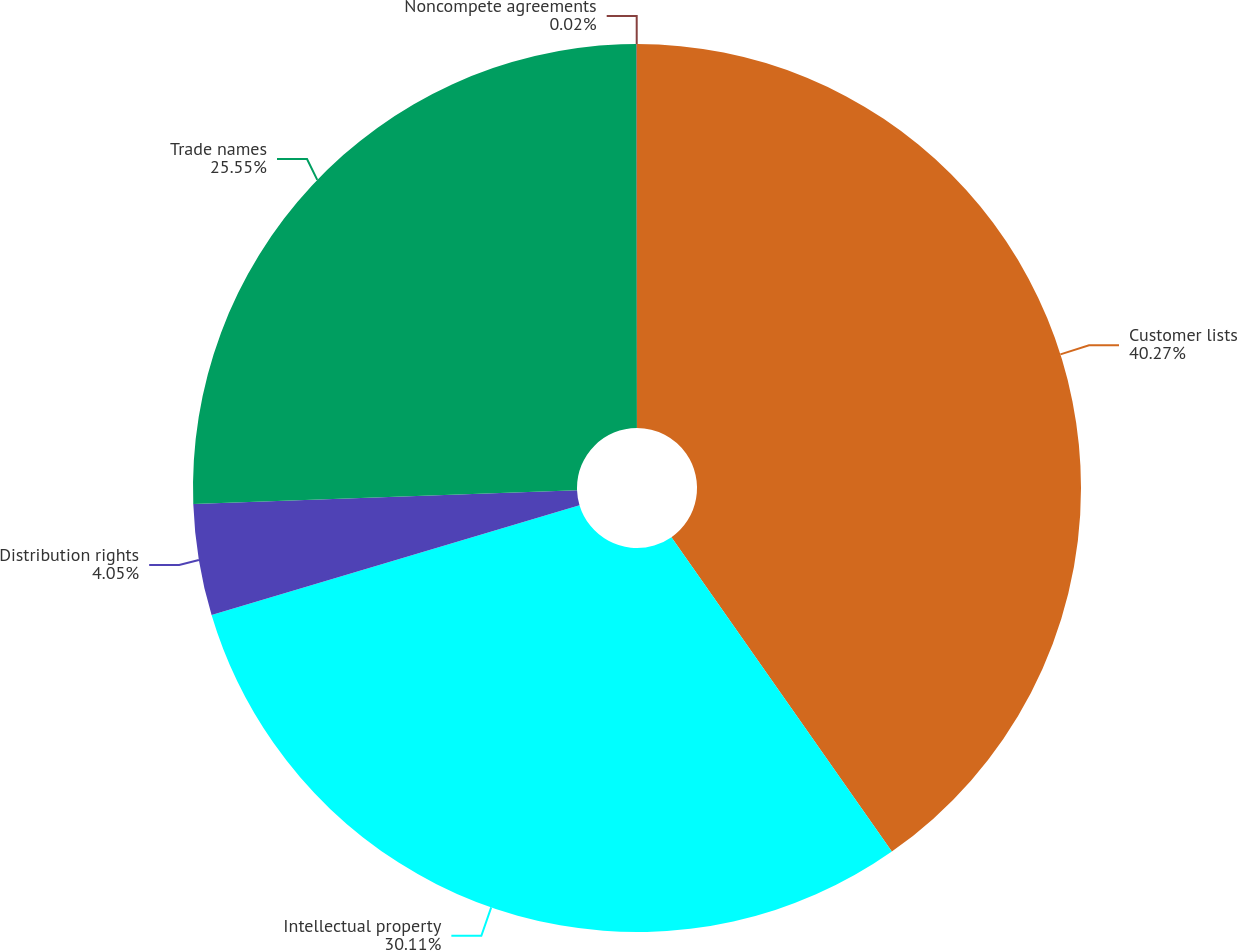Convert chart. <chart><loc_0><loc_0><loc_500><loc_500><pie_chart><fcel>Customer lists<fcel>Intellectual property<fcel>Distribution rights<fcel>Trade names<fcel>Noncompete agreements<nl><fcel>40.27%<fcel>30.11%<fcel>4.05%<fcel>25.55%<fcel>0.02%<nl></chart> 